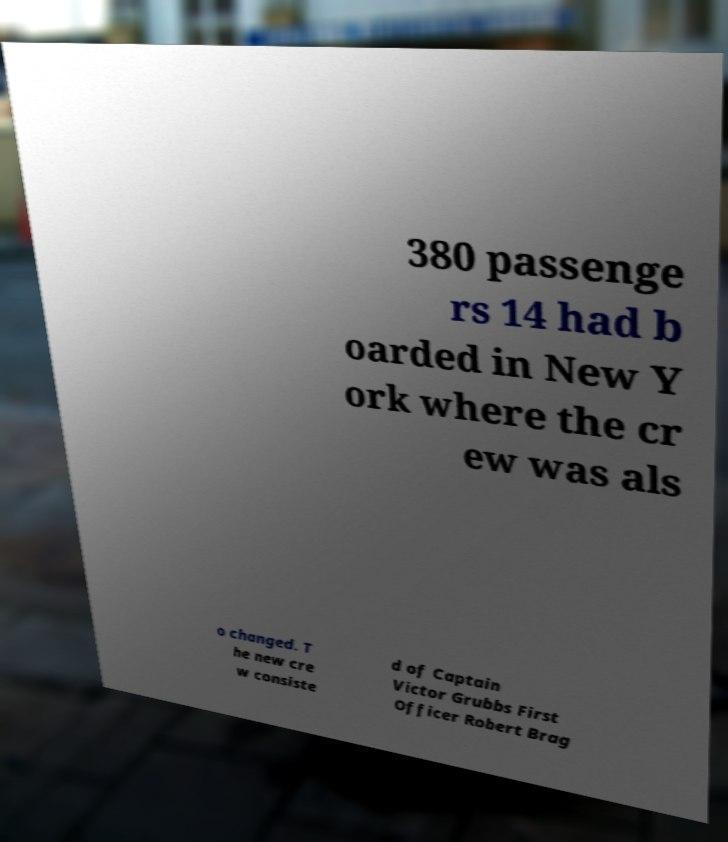There's text embedded in this image that I need extracted. Can you transcribe it verbatim? 380 passenge rs 14 had b oarded in New Y ork where the cr ew was als o changed. T he new cre w consiste d of Captain Victor Grubbs First Officer Robert Brag 